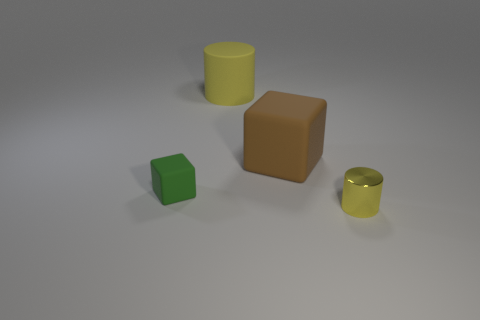Can you describe the colors and shapes of the objects in this image? Certainly! The image contains four objects: a green cube, a brown cube, a yellow cylinder, and a smaller yellow cylinder that resembles a cup. Both cubes have a matte finish, while the cylinders have a glossy, reflective surface. 